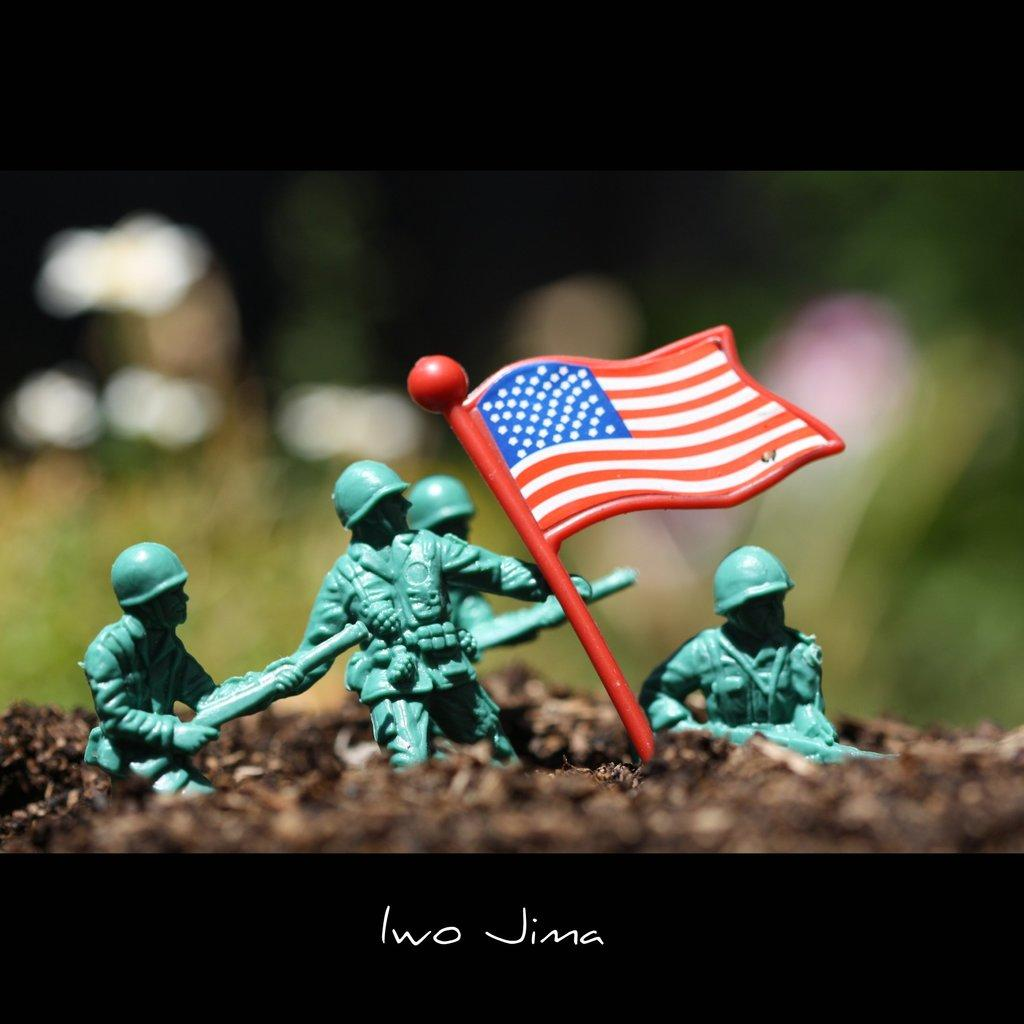What type of toy is present in the image? There are toys of a flag in the image. What protective gear are some persons wearing in the image? Some persons are wearing helmets in the image. Can you describe the background of the image? The background of the image is blurry. How many boats can be seen in the image? There are no boats present in the image. What word is written on the foot of the person in the image? There is no person or foot visible in the image. 